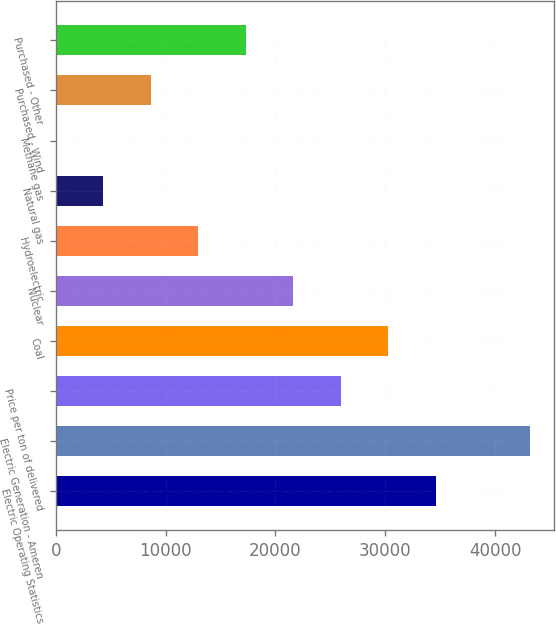<chart> <loc_0><loc_0><loc_500><loc_500><bar_chart><fcel>Electric Operating Statistics<fcel>Electric Generation - Ameren<fcel>Price per ton of delivered<fcel>Coal<fcel>Nuclear<fcel>Hydroelectric<fcel>Natural gas<fcel>Methane gas<fcel>Purchased - Wind<fcel>Purchased - Other<nl><fcel>34570.4<fcel>43213<fcel>25927.8<fcel>30249.1<fcel>21606.5<fcel>12964<fcel>4321.39<fcel>0.1<fcel>8642.68<fcel>17285.3<nl></chart> 